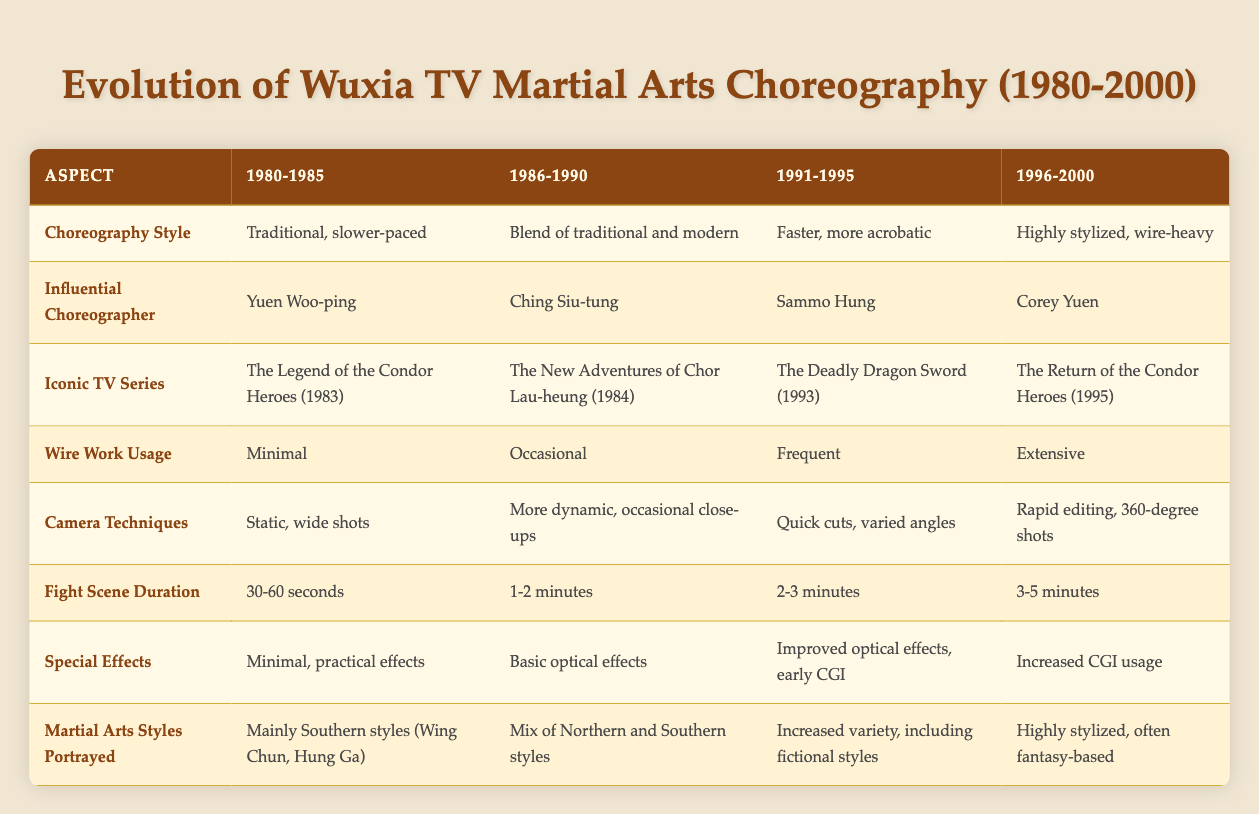What was the choreography style in 1985? Referring to the table under the aspect "Choreography Style," the entry for 1980-1985 indicates it was "Traditional, slower-paced."
Answer: Traditional, slower-paced Which choreographer influenced the 1991-1995 period? Looking at the "Influential Choreographer" row for the 1991-1995 column, it shows Sammo Hung as the key figure during that time.
Answer: Sammo Hung Did wire work usage increase from 1986-1990 to 1991-1995? The table indicates that wire work usage was "Occasional" in 1986-1990 and "Frequent" in 1991-1995, confirming that it indeed increased during this time.
Answer: Yes What is the average fight scene duration for the years 1991-2000? The fight scene durations specified are: 2-3 minutes for 1991-1995 and 3-5 minutes for 1996-2000. The average can be derived from the midpoint values: (2.5 + 4) / 2 = 3.25 minutes.
Answer: 3.25 minutes Which iconic TV series aired during 1986-1990? According to the "Iconic TV Series" row, the series noted for the 1986-1990 period is "The New Adventures of Chor Lau-heung (1984)."
Answer: The New Adventures of Chor Lau-heung (1984) Was there a significant shift in special effects from 1980-1985 to 1996-2000? Comparing the entries for special effects, it states "Minimal, practical effects" for 1980-1985 and "Increased CGI usage" for 1996-2000, indicating a significant shift towards more advanced effects over the years.
Answer: Yes How did the camera techniques evolve from 1980-2000? The table shows progression from "Static, wide shots" in 1980-1985, to "Rapid editing, 360-degree shots" in 1996-2000, indicating that camera techniques became significantly more dynamic and complex over this period.
Answer: Evolved significantly What was the main martial arts style portrayed in the 1980-1985 period? Under the "Martial Arts Styles Portrayed" row, the entry for 1980-1985 states "Mainly Southern styles (Wing Chun, Hung Ga)," indicating these were predominant during that era.
Answer: Mainly Southern styles (Wing Chun, Hung Ga) In which period was the choreography described as "Highly stylized, wire-heavy"? The description "Highly stylized, wire-heavy" appears in the 1996-2000 column under "Choreography Style."
Answer: 1996-2000 